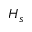Convert formula to latex. <formula><loc_0><loc_0><loc_500><loc_500>H _ { s }</formula> 